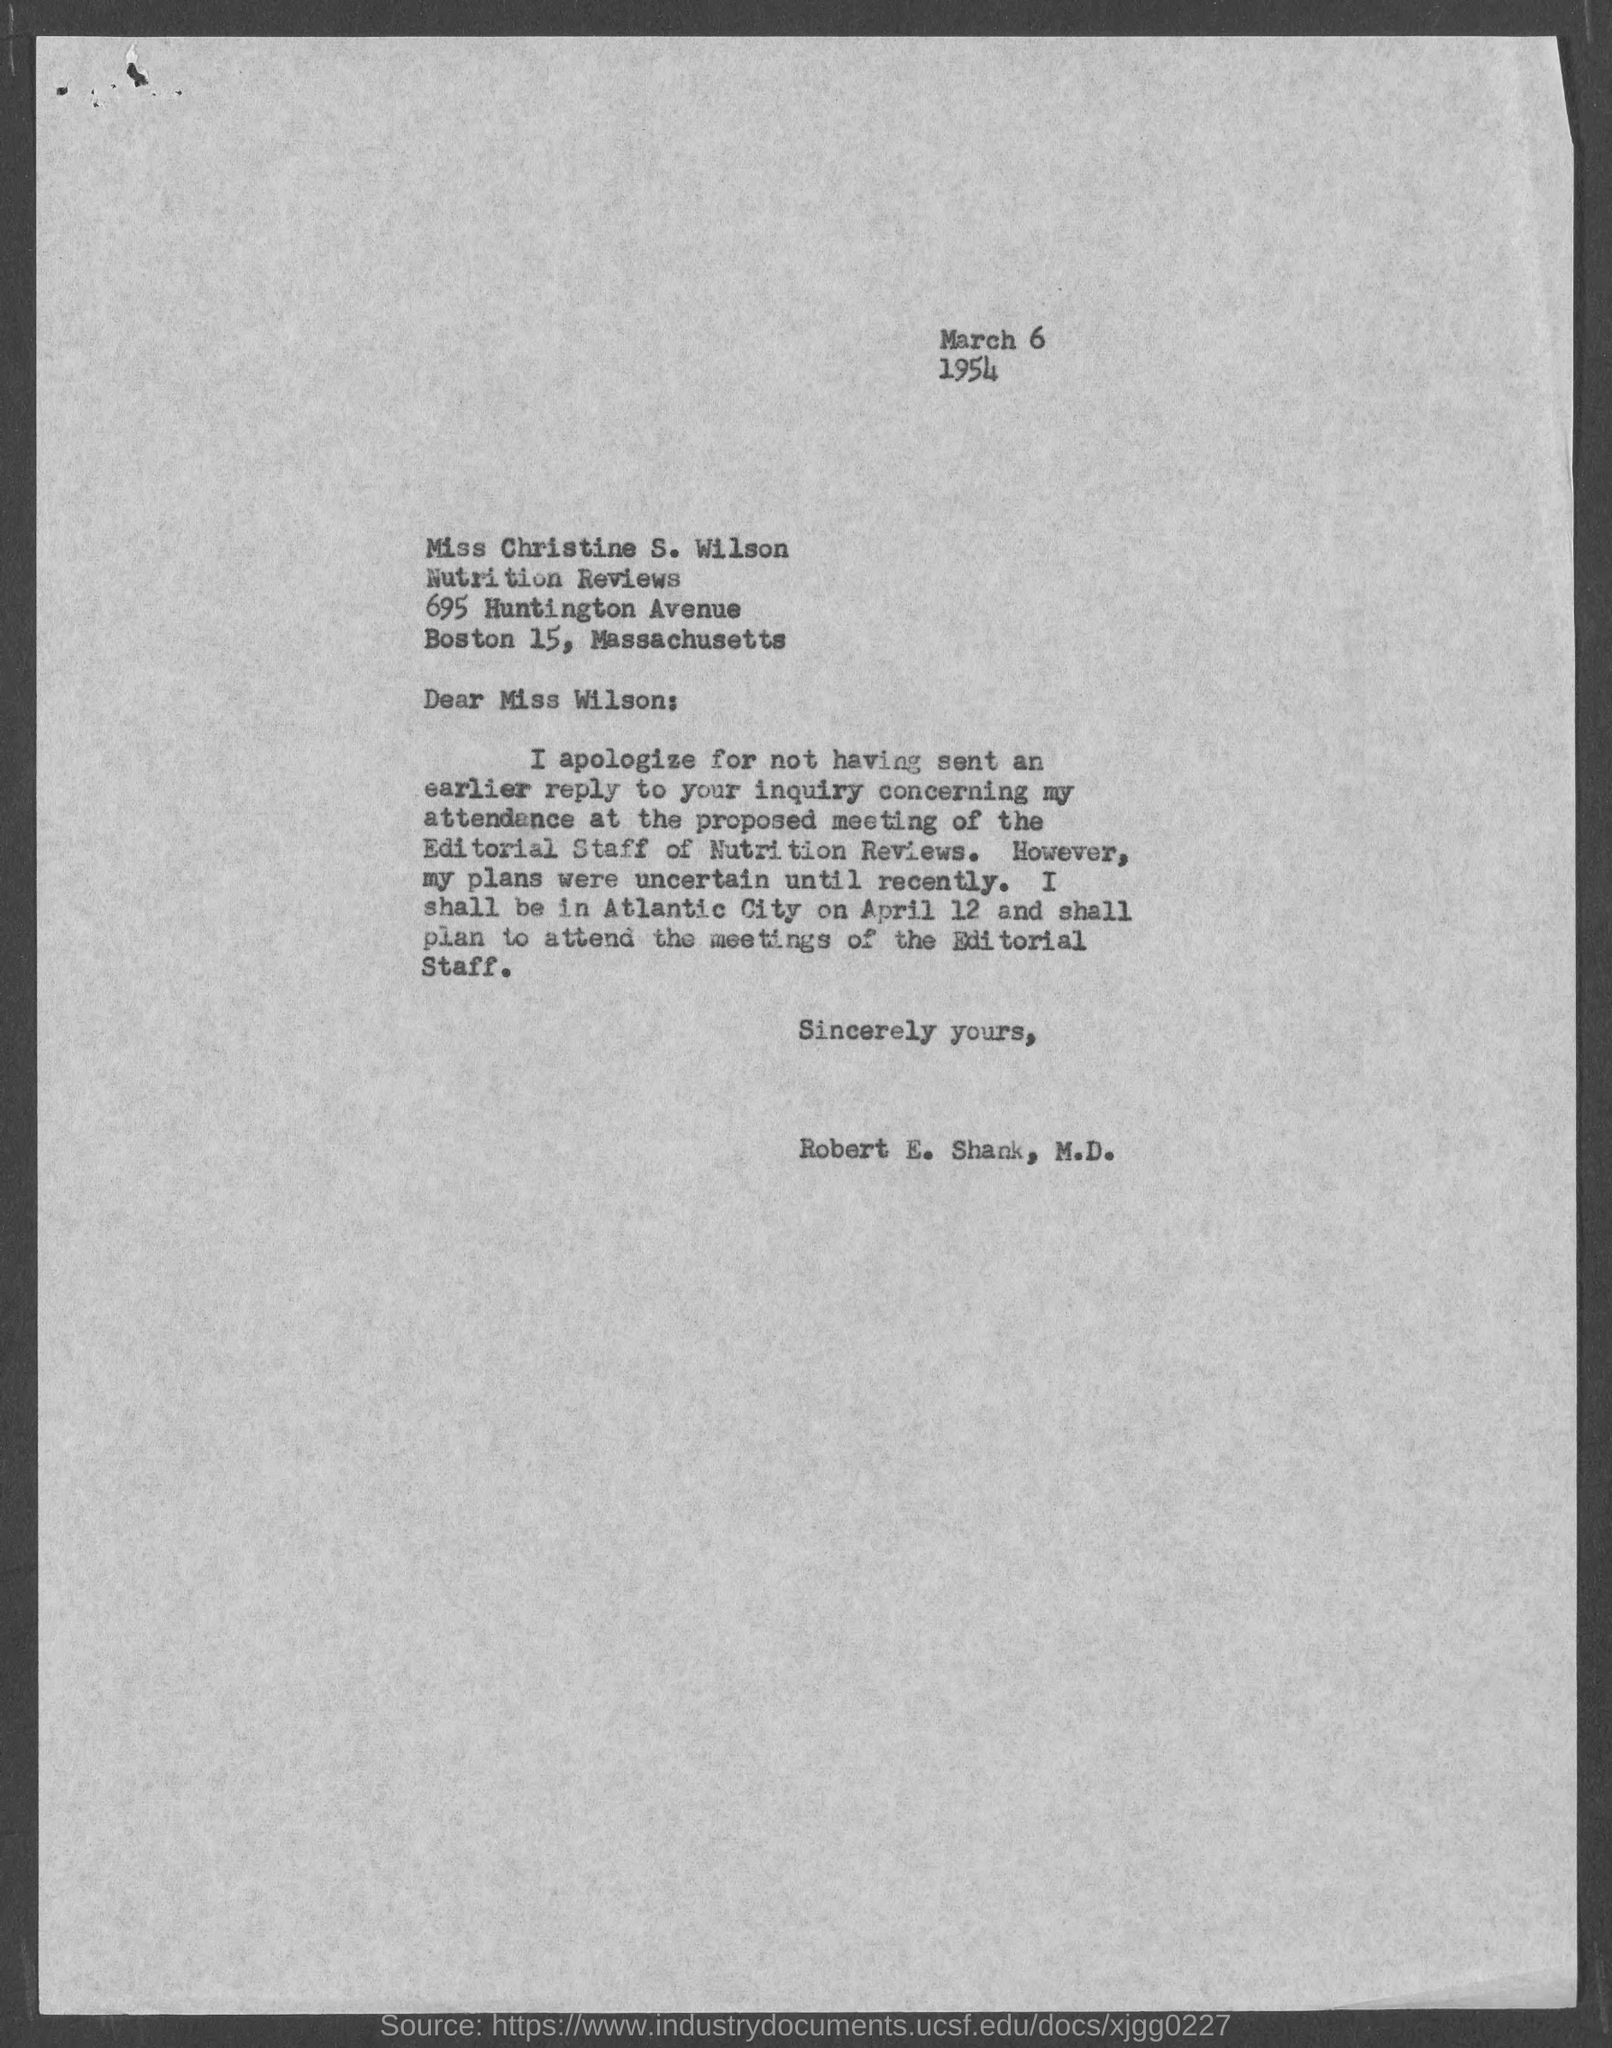Specify some key components in this picture. The letter is from Robert E. Shank, M.D. The document contains the date of March 6, 1954. The letter is addressed to Miss Christine S. Wilson. 